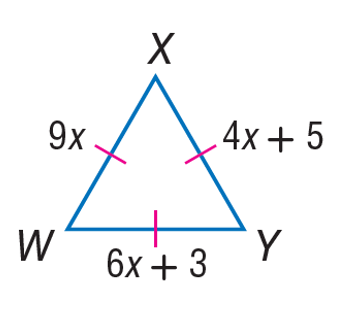Answer the mathemtical geometry problem and directly provide the correct option letter.
Question: Find the length of X W.
Choices: A: 4 B: 5 C: 6 D: 9 D 